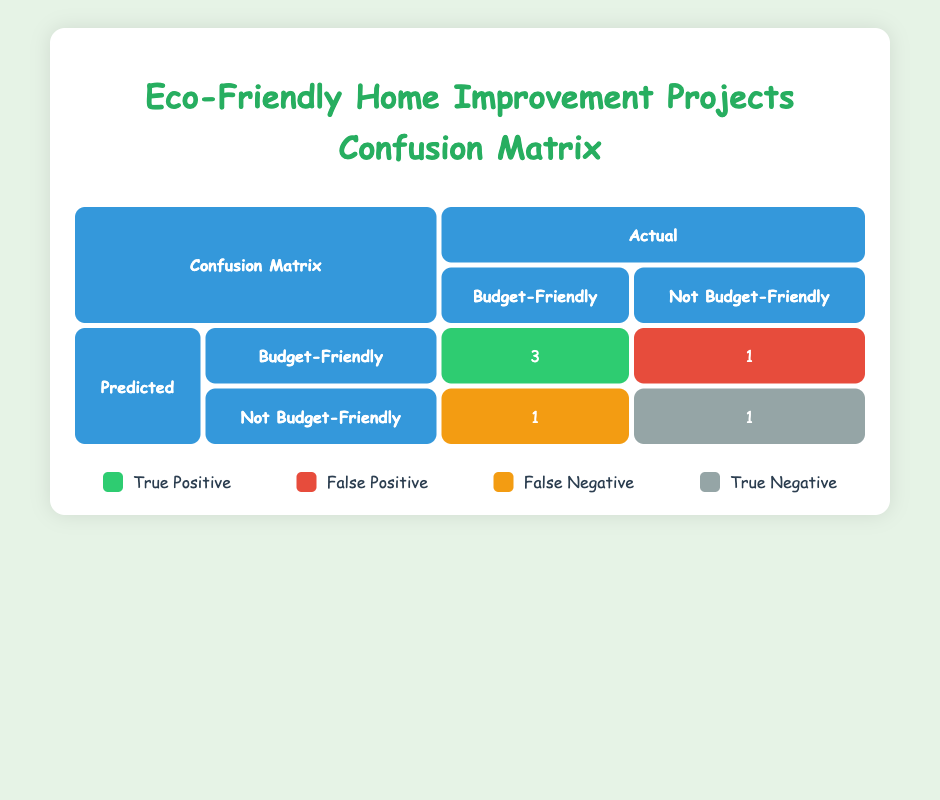What is the total number of budget-friendly home improvement projects? From the table, we see that there are three projects classified as budget-friendly: "Garden Planters", "Kitchen Backsplash", and "Roof Insulation".
Answer: 3 What is the number of successful home improvement projects that used recycled materials? The successful projects that used recycled materials are "Garden Planters", "Bathroom Renovation", "Kitchen Backsplash", and "Roof Insulation". Therefore, there are four successful projects.
Answer: 4 How many projects were categorized as not budget-friendly and also unsuccessful? The projects that are categorized as not budget-friendly and unsuccessful include "Deck Resurfacing" and "Living Room Remodel", totaling two projects.
Answer: 2 Did the project "Bathroom Renovation" stay within budget? The "Bathroom Renovation" project had a projected cost of 1200 but the actual cost was 1500, indicating that it exceeded the budget.
Answer: No What is the average actual cost of the budget-friendly projects? The actual costs of the budget-friendly projects are 40 (Garden Planters), 280 (Kitchen Backsplash), and 700 (Roof Insulation). The sum is 1020 and there are 3 budget-friendly projects, so the average is 1020/3 = 340.
Answer: 340 Which project had the highest actual cost among those marked not budget-friendly? Among the not budget-friendly projects, "Deck Resurfacing" had an actual cost of 2500, which is higher than the "Bathroom Renovation" (1500) and "Living Room Remodel" (1700).
Answer: Deck Resurfacing What is the ratio of successful projects to unsuccessful projects using recycled materials? There are four successful projects ("Garden Planters", "Bathroom Renovation", "Kitchen Backsplash", "Roof Insulation") and three unsuccessful projects ("Deck Resurfacing" and "Living Room Remodel"). Thus, the ratio is 4:3.
Answer: 4:3 How many projects are both eco-friendly and budget-friendly? The projects that are both eco-friendly and budget-friendly include "Garden Planters", "Kitchen Backsplash", and "Roof Insulation", totaling three projects.
Answer: 3 What percentage of the projects were successful? There are six projects in total, four of which were successful. The percentage is (4/6) * 100 = 66.67 percent.
Answer: 66.67% 